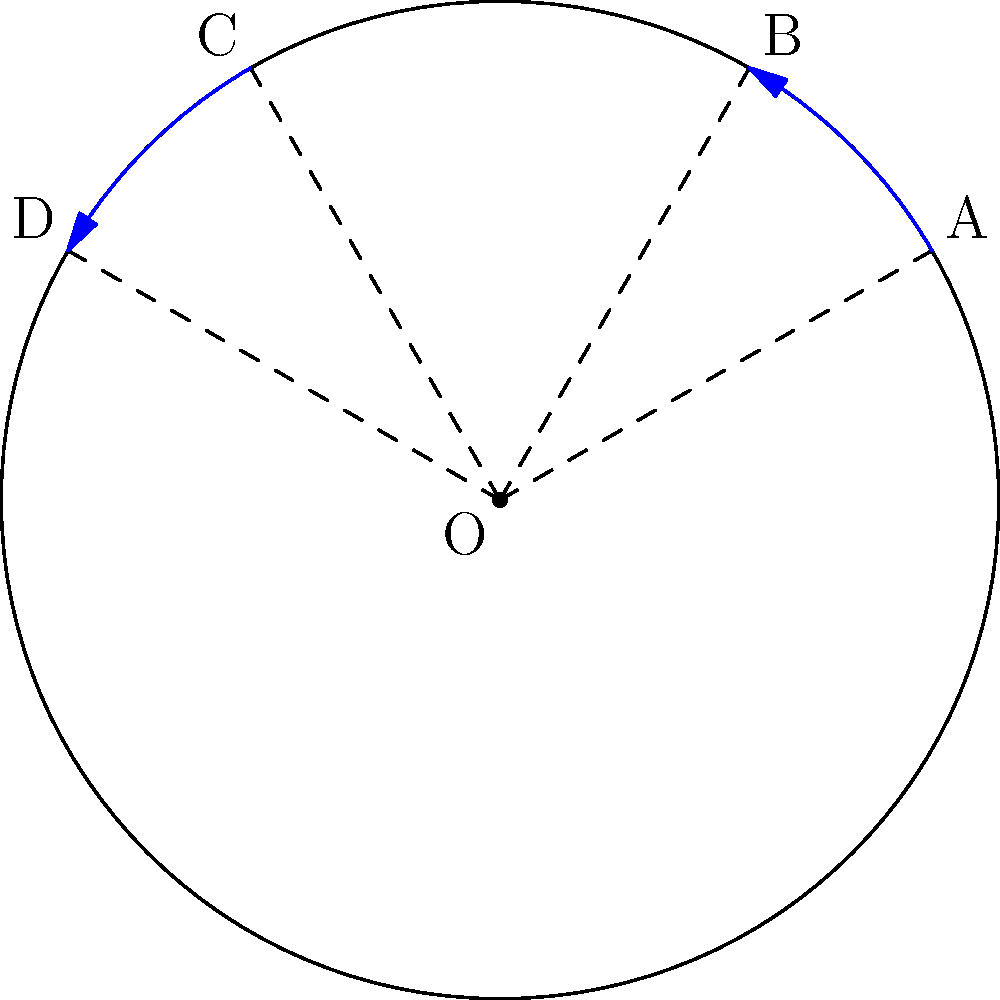In a circular field with radius 5 units, you want to install an irrigation system that covers two sectors: OAB and OCD, as shown in the diagram. If the polar equation of the field is $r = 5$, and the central angles of the sectors are $\frac{\pi}{6}$ and $\frac{\pi}{6}$ respectively, what is the total area of the field that will be irrigated? Let's approach this step-by-step:

1) The area of a sector in polar coordinates is given by the formula:
   $A = \frac{1}{2} \int_{\theta_1}^{\theta_2} r^2 d\theta$

2) For our circular field, $r = 5$ (constant).

3) For sector OAB:
   $\theta_1 = \frac{\pi}{6}$, $\theta_2 = \frac{\pi}{3}$
   $A_{OAB} = \frac{1}{2} \int_{\pi/6}^{\pi/3} 5^2 d\theta = \frac{25}{2} [\theta]_{\pi/6}^{\pi/3} = \frac{25}{2} \cdot \frac{\pi}{6} = \frac{25\pi}{12}$

4) For sector OCD:
   $\theta_1 = \frac{2\pi}{3}$, $\theta_2 = \frac{5\pi}{6}$
   $A_{OCD} = \frac{1}{2} \int_{2\pi/3}^{5\pi/6} 5^2 d\theta = \frac{25}{2} [\theta]_{2\pi/3}^{5\pi/6} = \frac{25}{2} \cdot \frac{\pi}{6} = \frac{25\pi}{12}$

5) Total irrigated area:
   $A_{total} = A_{OAB} + A_{OCD} = \frac{25\pi}{12} + \frac{25\pi}{12} = \frac{25\pi}{6}$

6) To simplify: $\frac{25\pi}{6} = \frac{25\pi}{6} \cdot \frac{1}{1} = \frac{25\pi}{6} \cdot \frac{5}{5} = \frac{125\pi}{30} = \frac{25\pi}{6}$ square units
Answer: $\frac{25\pi}{6}$ square units 